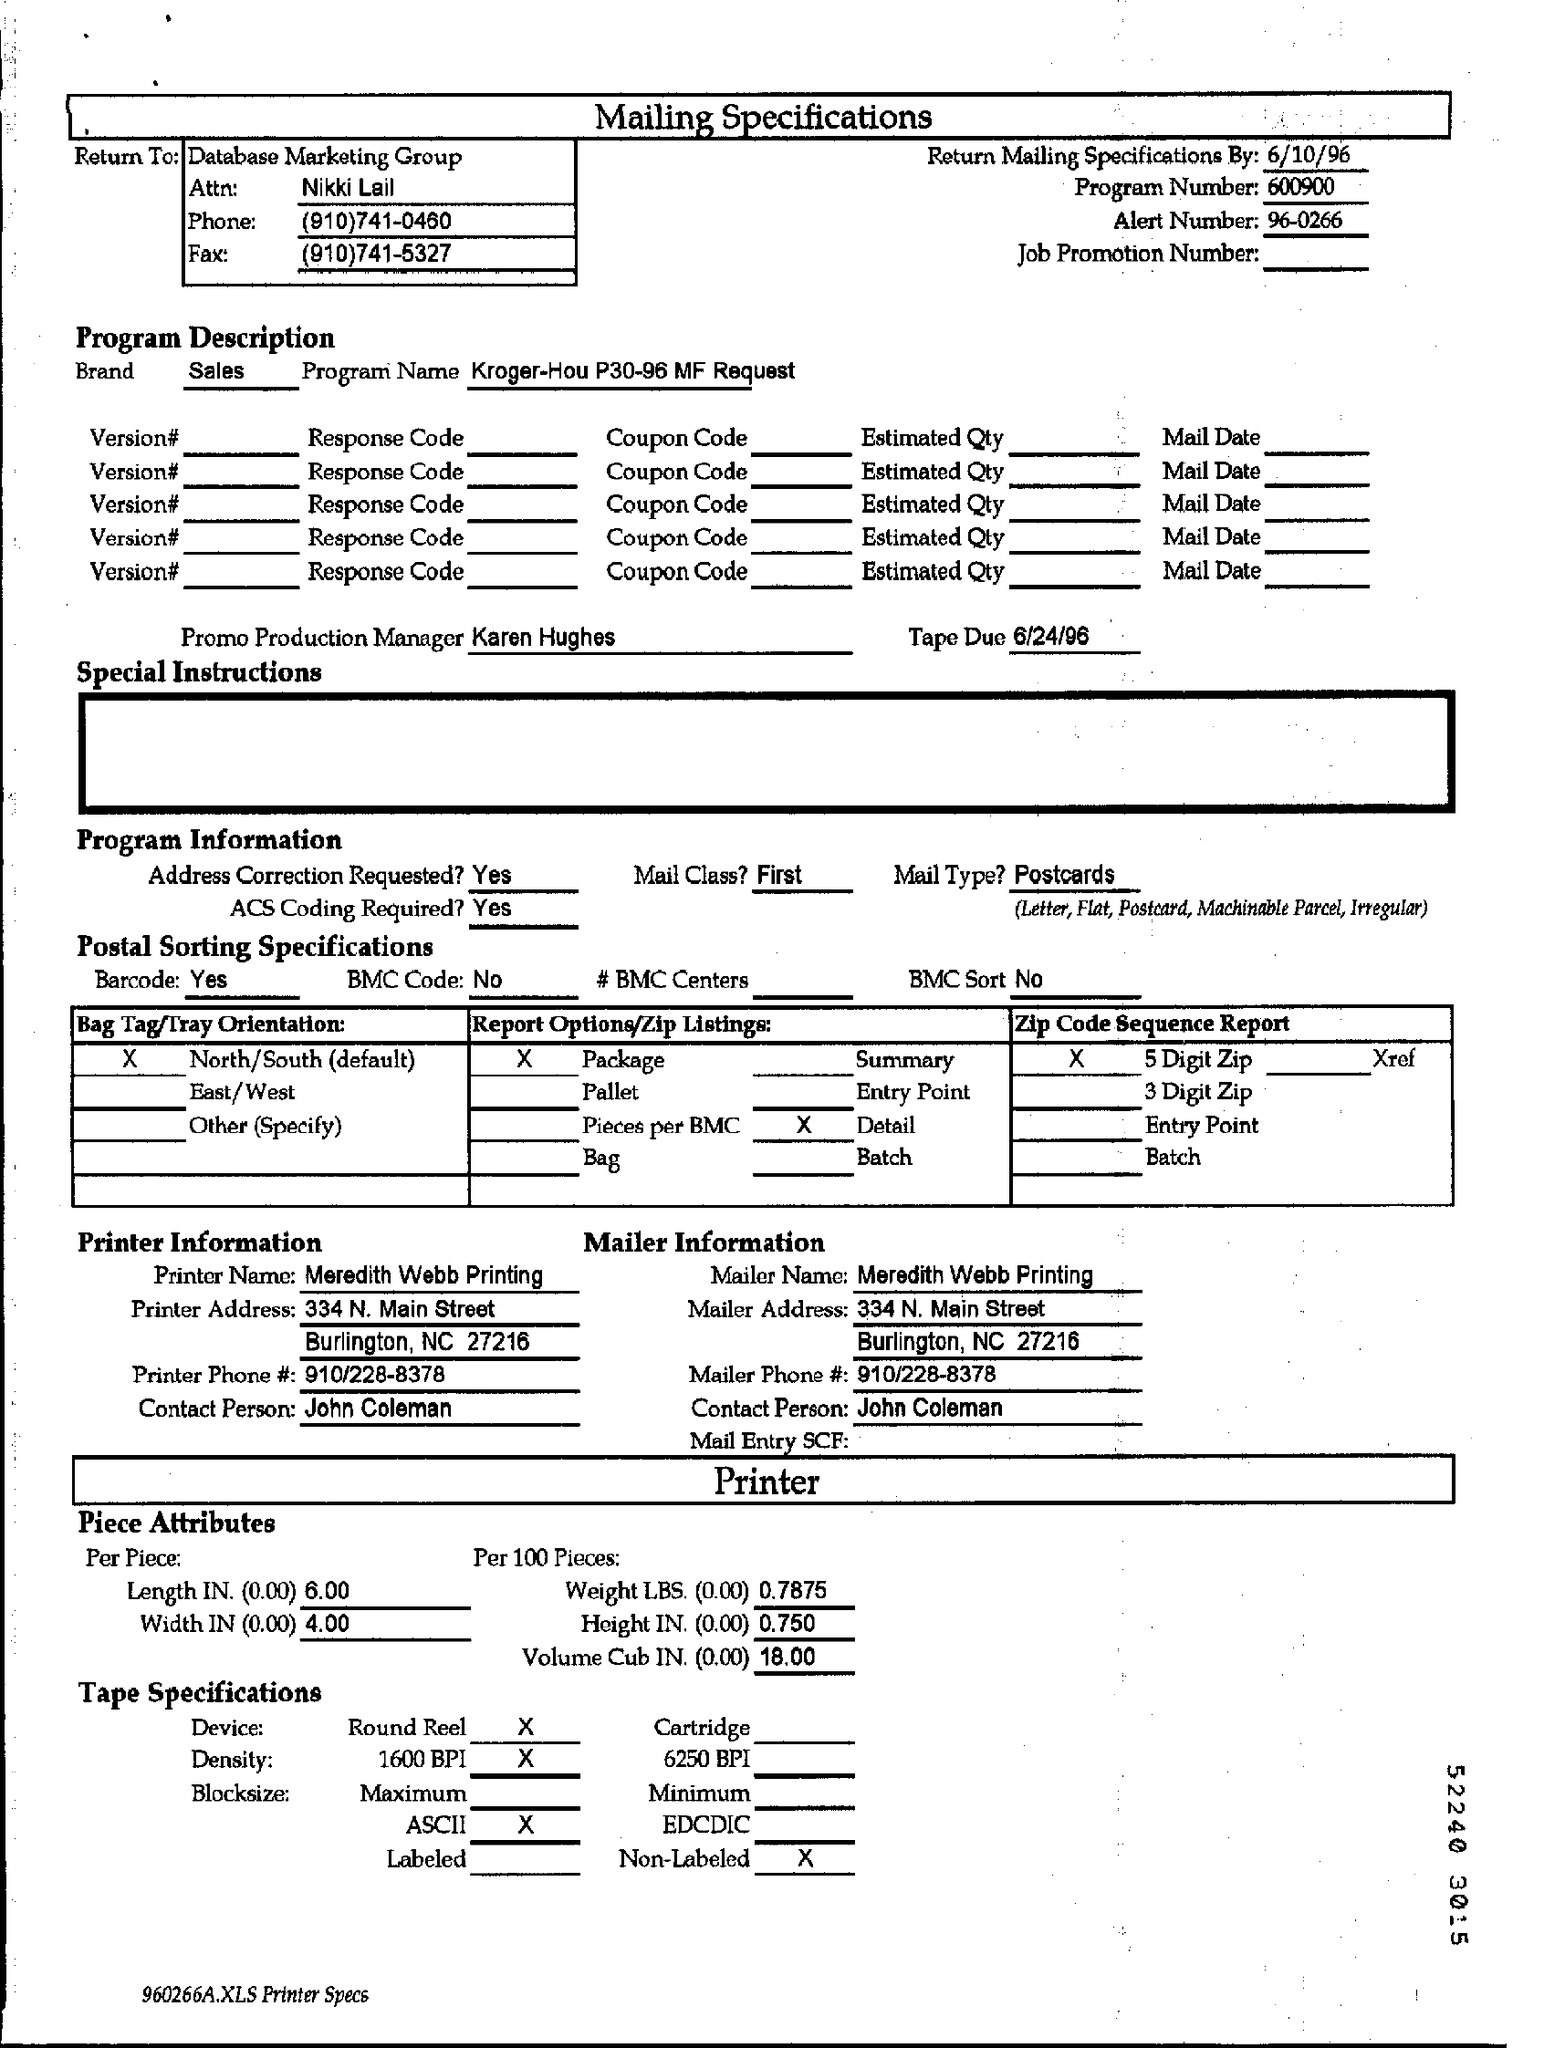What is the program number?
Your answer should be very brief. 600900. What is the tape due ?
Your response must be concise. 6/24/96. Who is the promo production manager ?
Offer a very short reply. Karen hughes. What is the alert number ?
Provide a short and direct response. 96-0266. What is the date for return mailing specifications ?
Your answer should be very brief. 6/10/96. What is the name of attn ?
Ensure brevity in your answer.  Nikki lail. For printer information who is the contact person ?
Make the answer very short. John Coleman. What is the phone number of data base marketing group
Provide a short and direct response. (910)741-0460. 